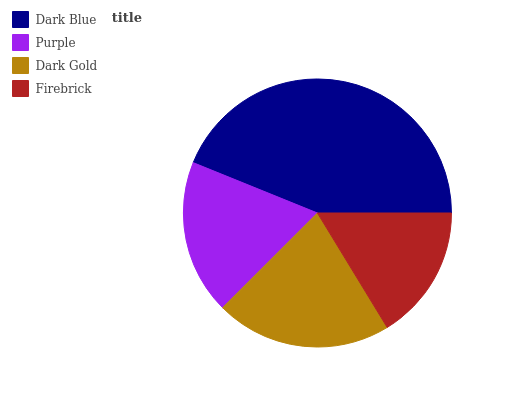Is Firebrick the minimum?
Answer yes or no. Yes. Is Dark Blue the maximum?
Answer yes or no. Yes. Is Purple the minimum?
Answer yes or no. No. Is Purple the maximum?
Answer yes or no. No. Is Dark Blue greater than Purple?
Answer yes or no. Yes. Is Purple less than Dark Blue?
Answer yes or no. Yes. Is Purple greater than Dark Blue?
Answer yes or no. No. Is Dark Blue less than Purple?
Answer yes or no. No. Is Dark Gold the high median?
Answer yes or no. Yes. Is Purple the low median?
Answer yes or no. Yes. Is Purple the high median?
Answer yes or no. No. Is Dark Blue the low median?
Answer yes or no. No. 